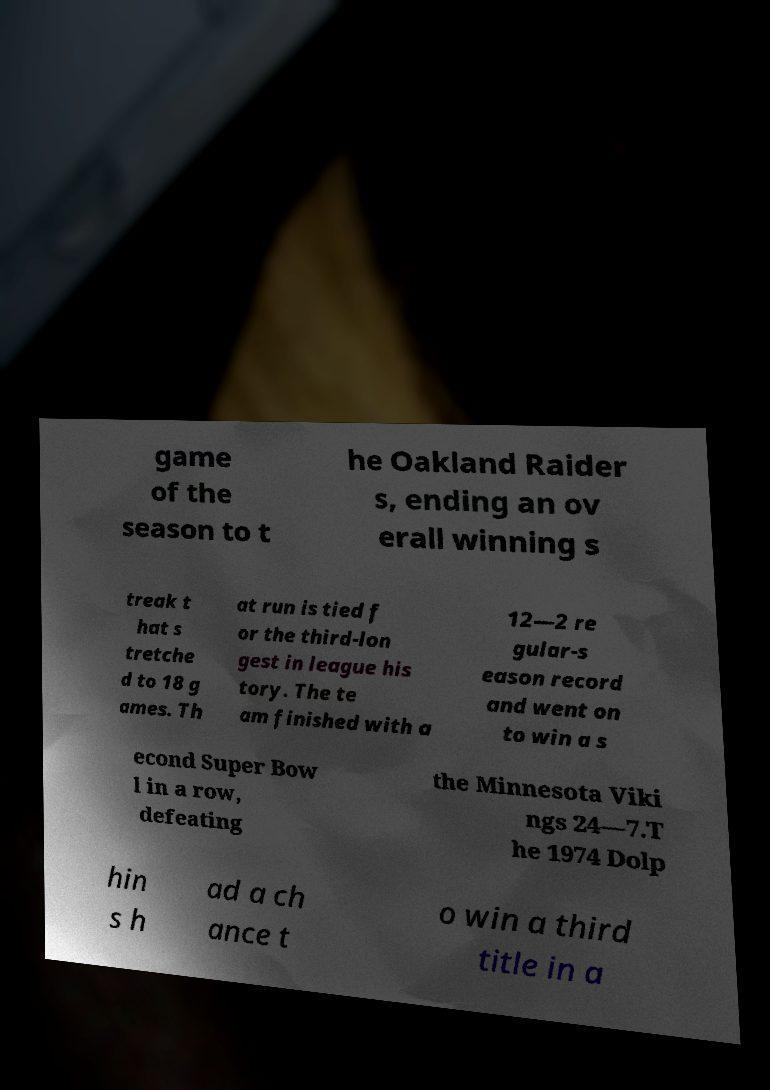Can you accurately transcribe the text from the provided image for me? game of the season to t he Oakland Raider s, ending an ov erall winning s treak t hat s tretche d to 18 g ames. Th at run is tied f or the third-lon gest in league his tory. The te am finished with a 12—2 re gular-s eason record and went on to win a s econd Super Bow l in a row, defeating the Minnesota Viki ngs 24—7.T he 1974 Dolp hin s h ad a ch ance t o win a third title in a 